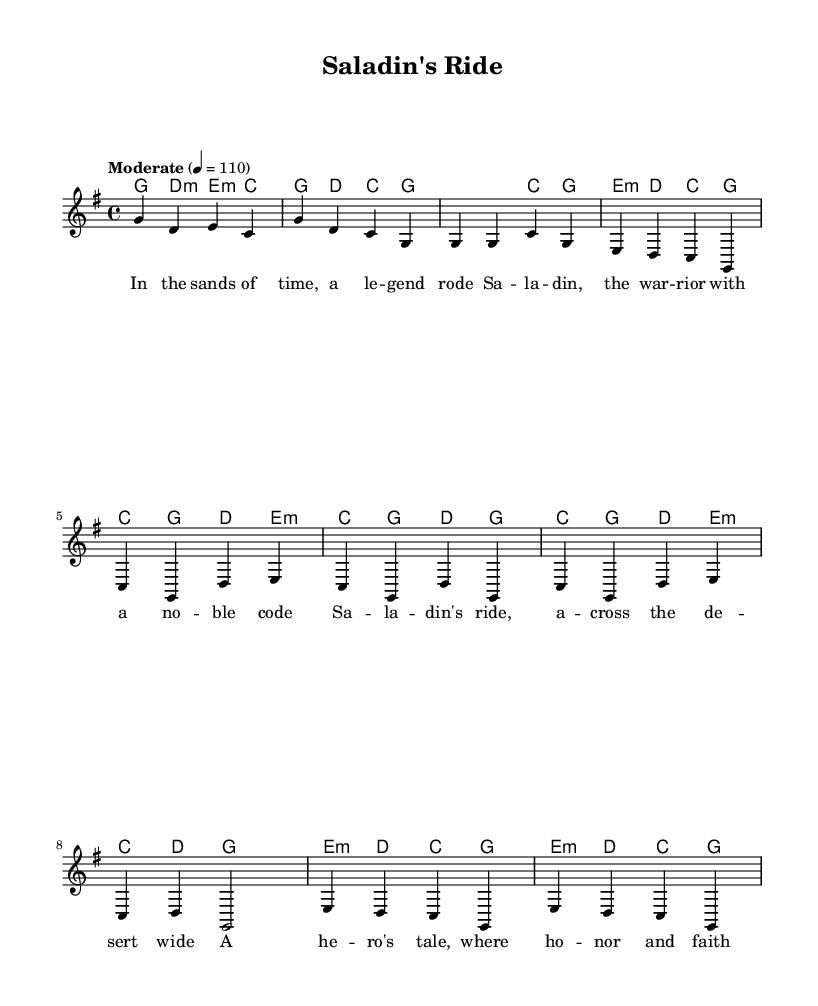What is the key signature of this music? The key signature is G major, which has one sharp (F#). This can be inferred from the ' \key g \major ' notation in the global section of the sheet music.
Answer: G major What is the time signature of this piece? The time signature is 4/4, indicated by the ' \time 4/4 ' notation in the global section. This means there are four beats per measure and a quarter note gets one beat.
Answer: 4/4 What is the tempo marking given in the score? The tempo marking is "Moderate" at 110 beats per minute, denoted by ' \tempo "Moderate" 4 = 110 ' in the global section. This indicates the speed at which the piece should be played.
Answer: Moderate 110 How many measures are in the chorus section? The chorus section consists of four measures, as indicated by the repeated layout of the lines in the ' \chorus ' block, showing four distinct phrases.
Answer: Four What is the name of the historical figure featured in this song? The song centers around Saladin, as clearly articulated in the lyrics that refer to "Saladin." This is evidenced by both the verse and chorus sections that mention his name directly.
Answer: Saladin What instruments are used in this score? The score features a staff for melody and chord names for harmonies, suggesting a vocal or instrumental accompaniment typical of country music. This can be determined from the presence of ' \new Staff ' and ' \new ChordNames ' elements in the score structure.
Answer: Voice and guitar chords What type of music is this piece categorized as? This piece is categorized as country music, as indicated by its style and lyrical content that reflects themes consistent with the country genre, such as storytelling and historical references.
Answer: Country 